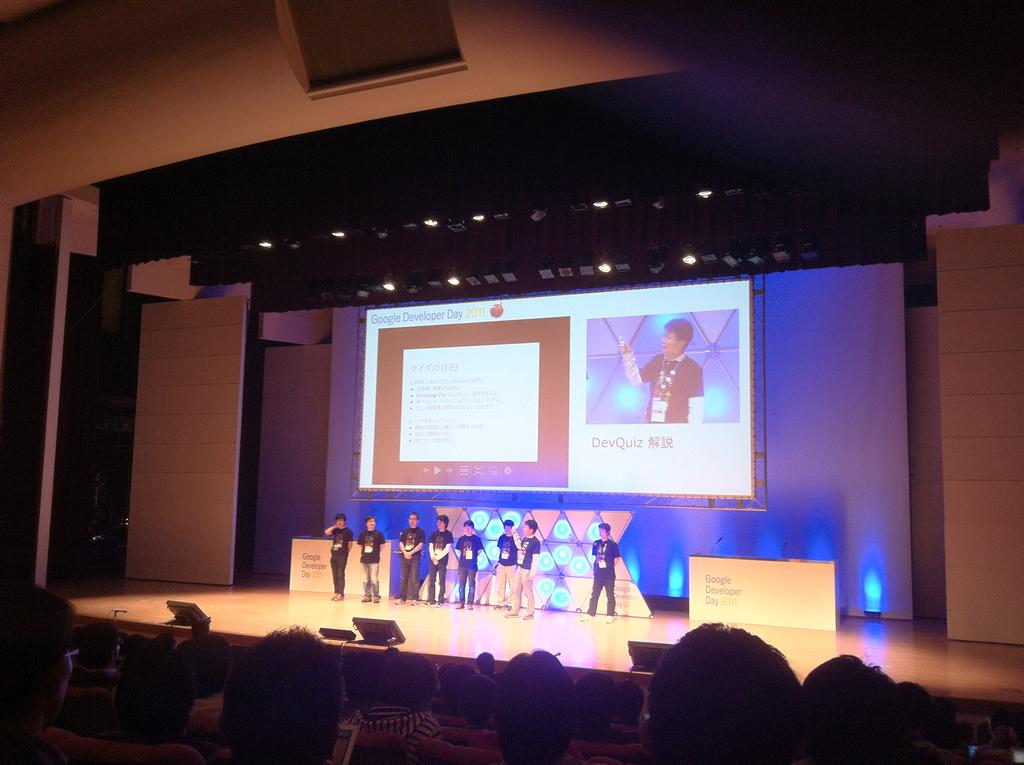What are the people in the image doing? There is a group of people sitting on chairs, and there are people standing on a stage, suggesting they might be attending an event or gathering. What can be seen on the stage? There are people standing on a stage, and there is a microphone (mic) present, indicating that they might be giving a presentation or performance. What is the purpose of the screen in the image? The screen in the image might be used for displaying visuals or information related to the event or gathering. What type of lighting is visible in the image? There are lights visible in the image, which could be used for illuminating the stage or creating a specific atmosphere. What type of structure is present in the image? There are walls in the image, suggesting that the event or gathering is taking place indoors. What other objects can be seen in the image? There are tables in the image, which might be used for seating or displaying items related to the event or gathering. What type of pot is being used to cook food on the table in the image? There is no pot or cooking activity present in the image; the tables are used for seating or displaying items related to the event or gathering. 